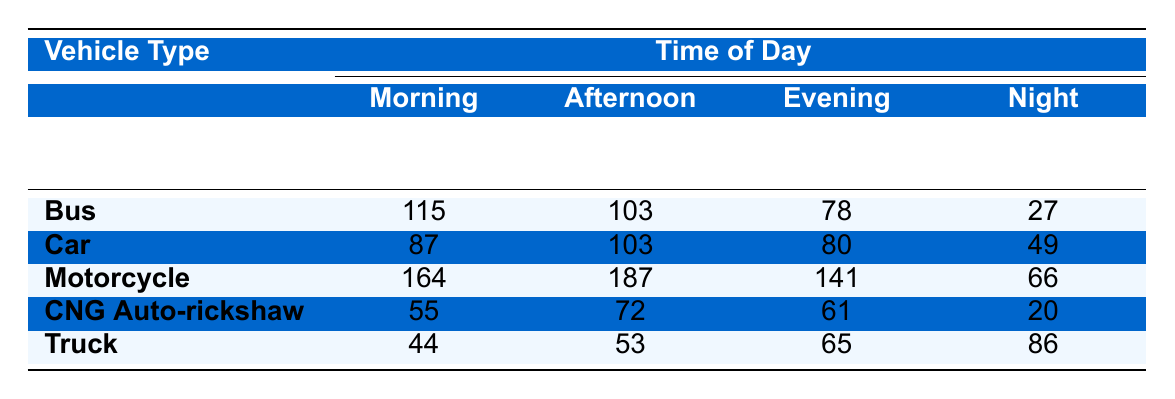What is the total number of road accidents for buses in the morning? To find the total number of road accidents for buses in the morning, we look at the first row of the table labeled "Bus" under the "Morning" column. The value is 115.
Answer: 115 Which vehicle type has the highest number of accidents in the evening? In the "Evening" column, we compare the values for each vehicle type. The Motorcycle has the highest value at 141, compared to others: Bus 78, Car 80, CNG Auto-rickshaw 61, and Truck 65.
Answer: Motorcycle What is the total number of motorcycle accidents from all cities during the afternoon? To find this, we add the motorcycle accident values from all cities' Afternoon column: Dhaka (62) + Chittagong (47) + Khulna (31) + Rajshahi (26) + Sylhet (21) = 187.
Answer: 187 How many accidents occurred for trucks during the night across all cities? We refer to the "Night" column under the Truck row and sum up the values from all cities: Dhaka (29) + Chittagong (21) + Khulna (14) + Rajshahi (12) + Sylhet (10) = 86.
Answer: 86 Is the number of CNG Auto-rickshaw accidents in the morning greater than the number of bus accidents in the night? The CNG Auto-rickshaw accidents in the morning are 55, and bus accidents in the night are 27. Since 55 > 27, the statement is true.
Answer: Yes Which type of vehicle has the least number of accidents during the night? In the Night column, we examine the values: Bus (27), Car (49), Motorcycle (66), CNG Auto-rickshaw (20), Truck (86). The least is CNG Auto-rickshaw with 20 accidents.
Answer: CNG Auto-rickshaw What is the average number of accidents for cars during the morning across all cities? To calculate the average, we sum the car accidents in the morning from each city: Dhaka (31) + Chittagong (22) + Khulna (14) + Rajshahi (11) + Sylhet (9) = 87, then divide by 5 (the number of cities), giving 87/5 = 17.4.
Answer: 17.4 Which time of day has the maximum total number of accidents across all motorcycle accidents? We sum the values for motorcycles in all time periods: Morning (164) + Afternoon (187) + Evening (141) + Night (66) = 558. The Afternoon has the maximum at 187.
Answer: Afternoon Does the total number of road accidents for all vehicle types during the morning exceed 400? The sum of accidents during the morning for all vehicle types is: Bus (115) + Car (87) + Motorcycle (164) + CNG Auto-rickshaw (55) + Truck (44) = 465, which exceeds 400.
Answer: Yes What is the difference in the number of accidents between motorcycles in the afternoon and buses in the evening? We find the values: Motorcycle in Afternoon is 187 and Bus in Evening is 78. The difference is 187 - 78 = 109.
Answer: 109 